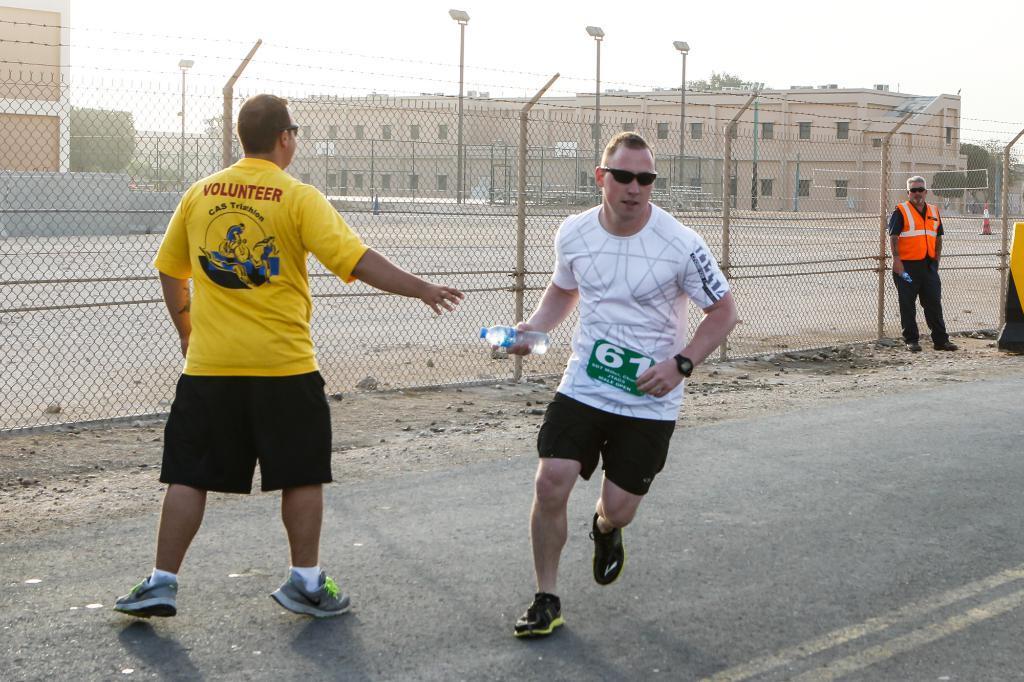How would you summarize this image in a sentence or two? In this image there are a few people standing, another person holding a bottle and running on the road, behind them there is a net fence, few street lights, buildings, trees, traffic safety and in the background there is the sky. 